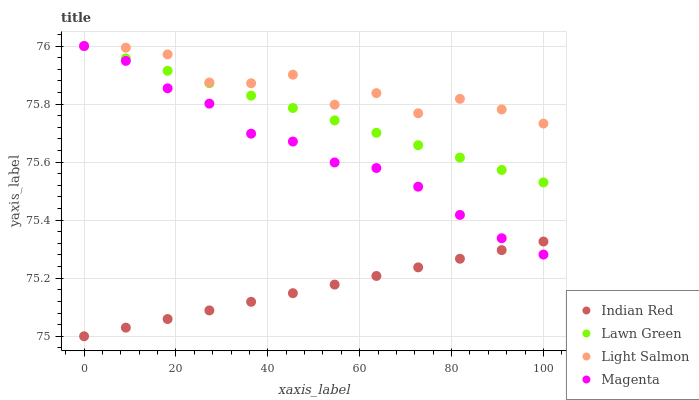Does Indian Red have the minimum area under the curve?
Answer yes or no. Yes. Does Light Salmon have the maximum area under the curve?
Answer yes or no. Yes. Does Magenta have the minimum area under the curve?
Answer yes or no. No. Does Magenta have the maximum area under the curve?
Answer yes or no. No. Is Lawn Green the smoothest?
Answer yes or no. Yes. Is Light Salmon the roughest?
Answer yes or no. Yes. Is Magenta the smoothest?
Answer yes or no. No. Is Magenta the roughest?
Answer yes or no. No. Does Indian Red have the lowest value?
Answer yes or no. Yes. Does Magenta have the lowest value?
Answer yes or no. No. Does Magenta have the highest value?
Answer yes or no. Yes. Does Indian Red have the highest value?
Answer yes or no. No. Is Indian Red less than Lawn Green?
Answer yes or no. Yes. Is Light Salmon greater than Indian Red?
Answer yes or no. Yes. Does Indian Red intersect Magenta?
Answer yes or no. Yes. Is Indian Red less than Magenta?
Answer yes or no. No. Is Indian Red greater than Magenta?
Answer yes or no. No. Does Indian Red intersect Lawn Green?
Answer yes or no. No. 